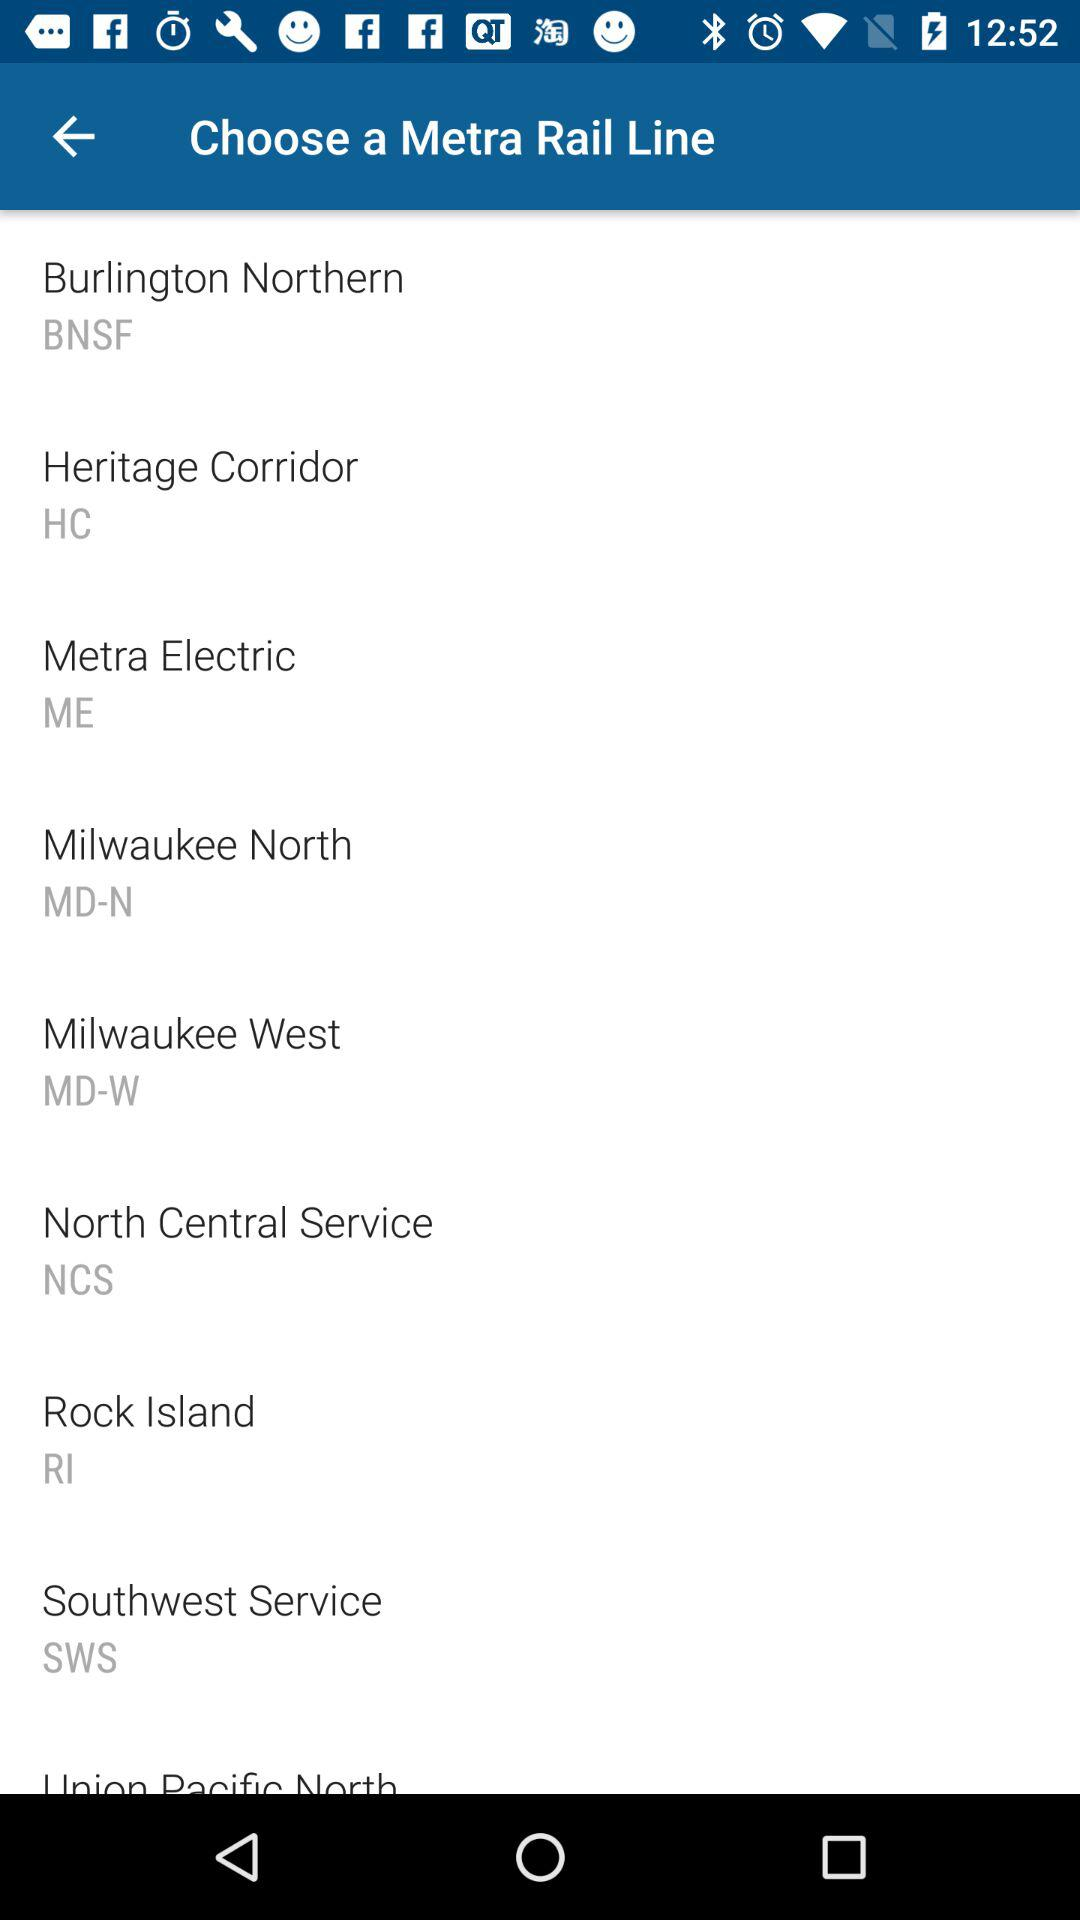How many lines are there?
Answer the question using a single word or phrase. 9 